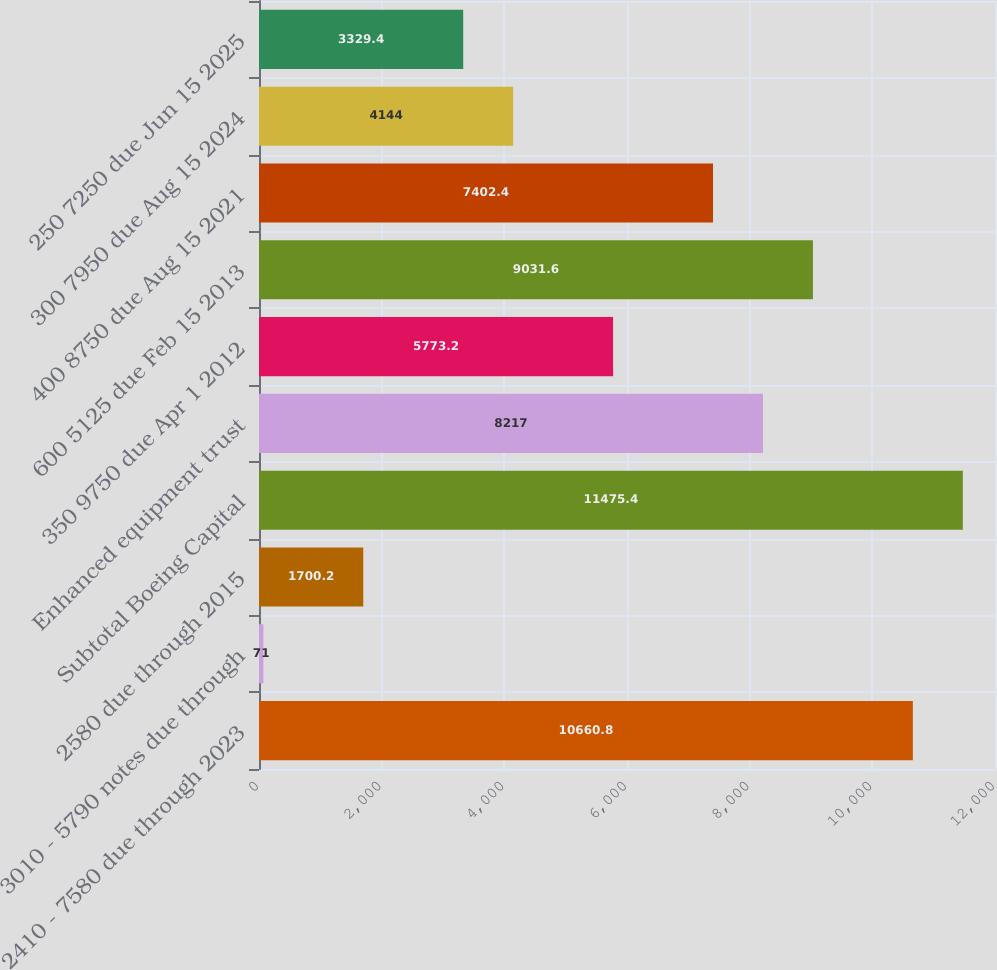Convert chart to OTSL. <chart><loc_0><loc_0><loc_500><loc_500><bar_chart><fcel>2410 - 7580 due through 2023<fcel>3010 - 5790 notes due through<fcel>2580 due through 2015<fcel>Subtotal Boeing Capital<fcel>Enhanced equipment trust<fcel>350 9750 due Apr 1 2012<fcel>600 5125 due Feb 15 2013<fcel>400 8750 due Aug 15 2021<fcel>300 7950 due Aug 15 2024<fcel>250 7250 due Jun 15 2025<nl><fcel>10660.8<fcel>71<fcel>1700.2<fcel>11475.4<fcel>8217<fcel>5773.2<fcel>9031.6<fcel>7402.4<fcel>4144<fcel>3329.4<nl></chart> 